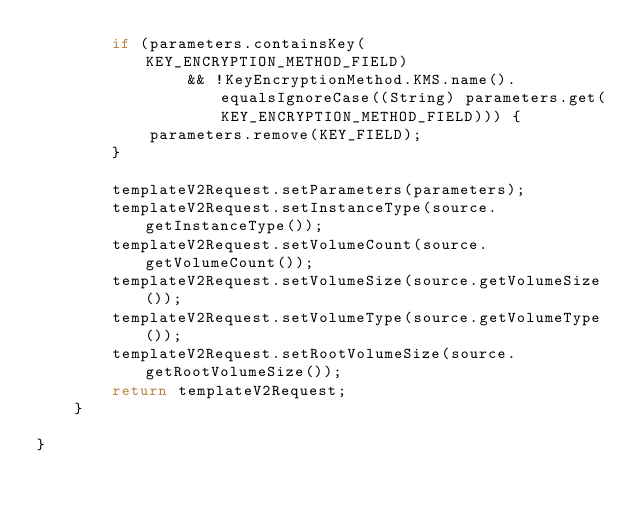Convert code to text. <code><loc_0><loc_0><loc_500><loc_500><_Java_>        if (parameters.containsKey(KEY_ENCRYPTION_METHOD_FIELD)
                && !KeyEncryptionMethod.KMS.name().equalsIgnoreCase((String) parameters.get(KEY_ENCRYPTION_METHOD_FIELD))) {
            parameters.remove(KEY_FIELD);
        }

        templateV2Request.setParameters(parameters);
        templateV2Request.setInstanceType(source.getInstanceType());
        templateV2Request.setVolumeCount(source.getVolumeCount());
        templateV2Request.setVolumeSize(source.getVolumeSize());
        templateV2Request.setVolumeType(source.getVolumeType());
        templateV2Request.setRootVolumeSize(source.getRootVolumeSize());
        return templateV2Request;
    }

}
</code> 